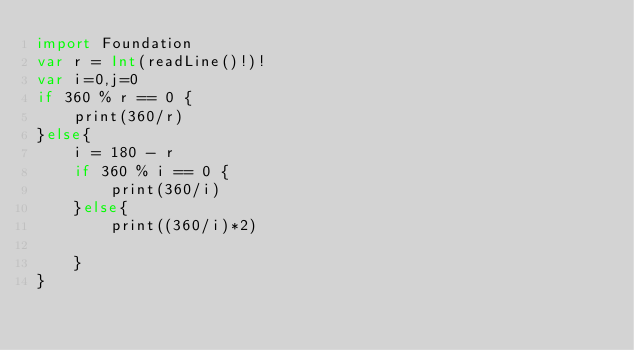<code> <loc_0><loc_0><loc_500><loc_500><_Swift_>import Foundation
var r = Int(readLine()!)!
var i=0,j=0
if 360 % r == 0 {
    print(360/r)
}else{
    i = 180 - r
    if 360 % i == 0 {
        print(360/i)
    }else{
        print((360/i)*2)
 
    }
}</code> 